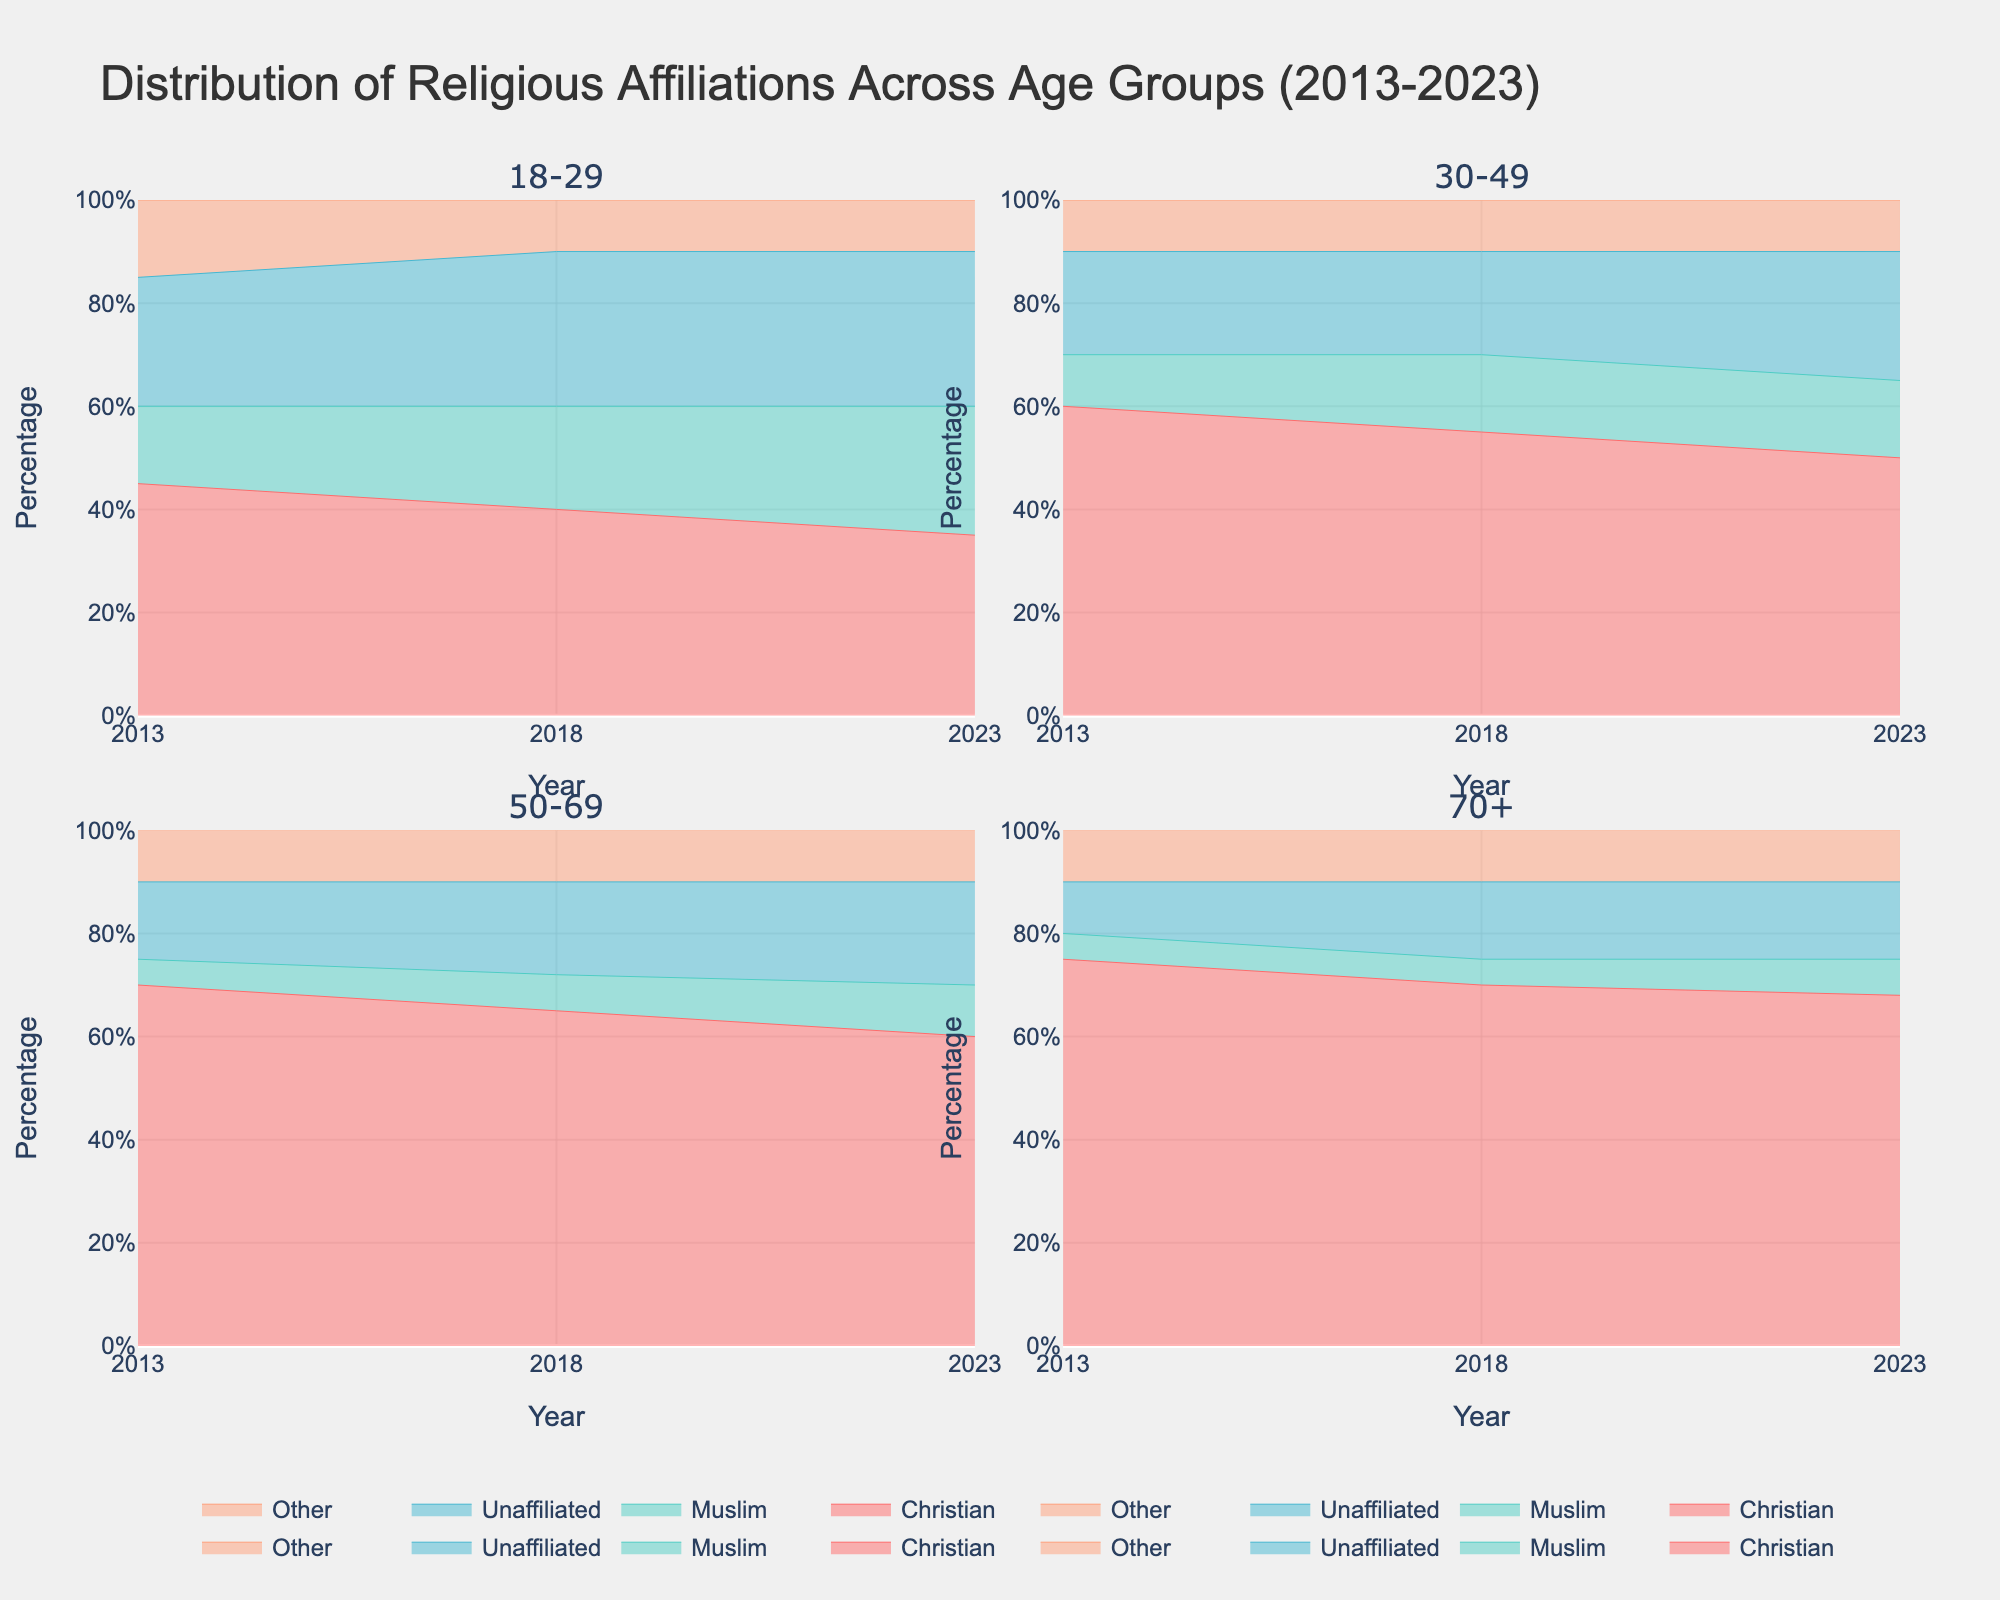What's the title of the figure? The title is located at the top of the figure and provides an overview of the visualized data. In this case, it describes the distribution of religious affiliations across different age groups over a decade.
Answer: Distribution of Religious Affiliations Across Age Groups (2013-2023) How many subplots are there in the figure? The figure is divided into different sections for better visualization, where each section represents a subplot. In this figure, there are subplots for each age group. There are two rows and two columns of subplots, making a total of 4 subplots.
Answer: 4 Which religious group had the highest percentage in the 18-29 age group in 2023? To find this, look at the 18-29 age group subplot and identify the highest area segment for the year 2023. The color that occupies the largest area indicates the group with the highest percentage.
Answer: Muslim Did the percentage of 'Unaffiliated' in the 30-49 age group increase or decrease from 2013 to 2023? By locating the 30-49 age group subplot, we observe the trend for the 'Unaffiliated' category from 2013 to 2023. The percentage increased from 20% in 2013 to 25% in 2023.
Answer: Increase Which age group saw the largest decrease in the percentage of Christians from 2013 to 2023? We need to compare the percentage of Christians in each age group between 2013 and 2023. The 18-29 age group had the largest decrease from 45% in 2013 to 35% in 2023.
Answer: 18-29 What was the trend for the 'Other' religious group in the 70+ age group from 2013 to 2023? By analyzing the 70+ age group subplot, we can see the trend of the 'Other' religious group. The percentage for 'Other' remained consistent at 10% over the decade.
Answer: Consistent In which year did 'Muslim' in the 18-29 age group surpass 'Christian' in percentage? By examining the 18-29 age group subplot, we notice that the percentage of 'Muslim' surpassed 'Christian' in 2023.
Answer: 2023 Compare the percentage change of 'Unaffiliated' in the 50-69 age group to the percentage change of 'Muslim' in the same age group from 2013 to 2023. For 'Unaffiliated', the percentage increased from 15% in 2013 to 20% in 2023, a change of +5%. For 'Muslim', the percentage increased from 5% to 10%, a change of +5%. So, both religious groups saw a change of +5% each in the 50-69 age group from 2013 to 2023.
Answer: Same change (+5%) Which age group had the highest percentage of Christians in 2018? By looking at the different subplots for each age group in 2018, the age group 70+ had the highest percentage of Christians at 70%.
Answer: 70+ What is the overall trend for the 'Christian' group across all age groups from 2013 to 2023? By observing the subplots for each age group, we can see if the 'Christian' group's percentage increased or decreased. We see a consistent decline in each age group over the decade.
Answer: Declining 